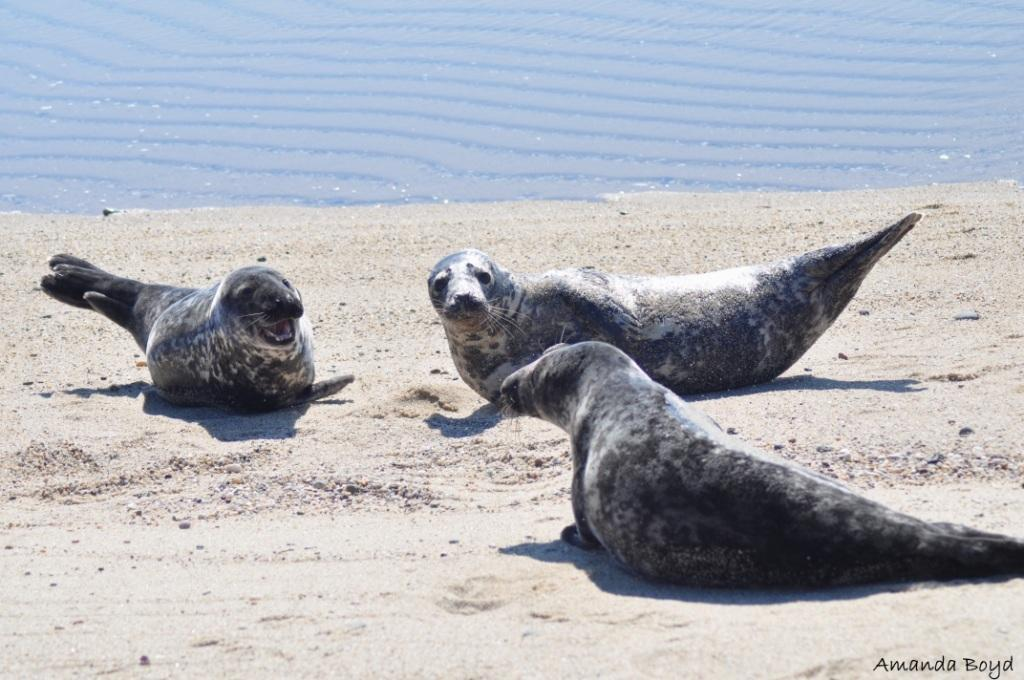What animals can be seen on the sea shore in the image? There are three harbor seals on the sea shore in the image. What large body of water is visible in the image? The ocean is visible in the image. Is there any text present in the image? Yes, there is text on the image. What type of army is depicted in the image? There is no army present in the image; it features harbor seals on the sea shore and the ocean. Can you see any guns in the image? There are no guns present in the image. 